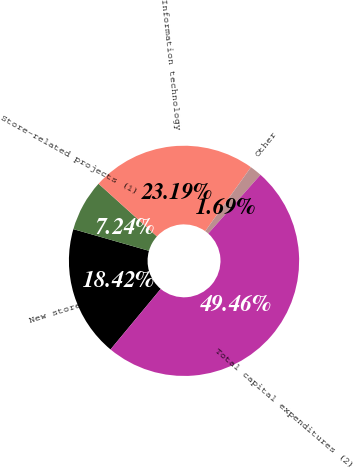<chart> <loc_0><loc_0><loc_500><loc_500><pie_chart><fcel>New stores<fcel>Store-related projects (1)<fcel>Information technology<fcel>Other<fcel>Total capital expenditures (2)<nl><fcel>18.42%<fcel>7.24%<fcel>23.19%<fcel>1.69%<fcel>49.46%<nl></chart> 